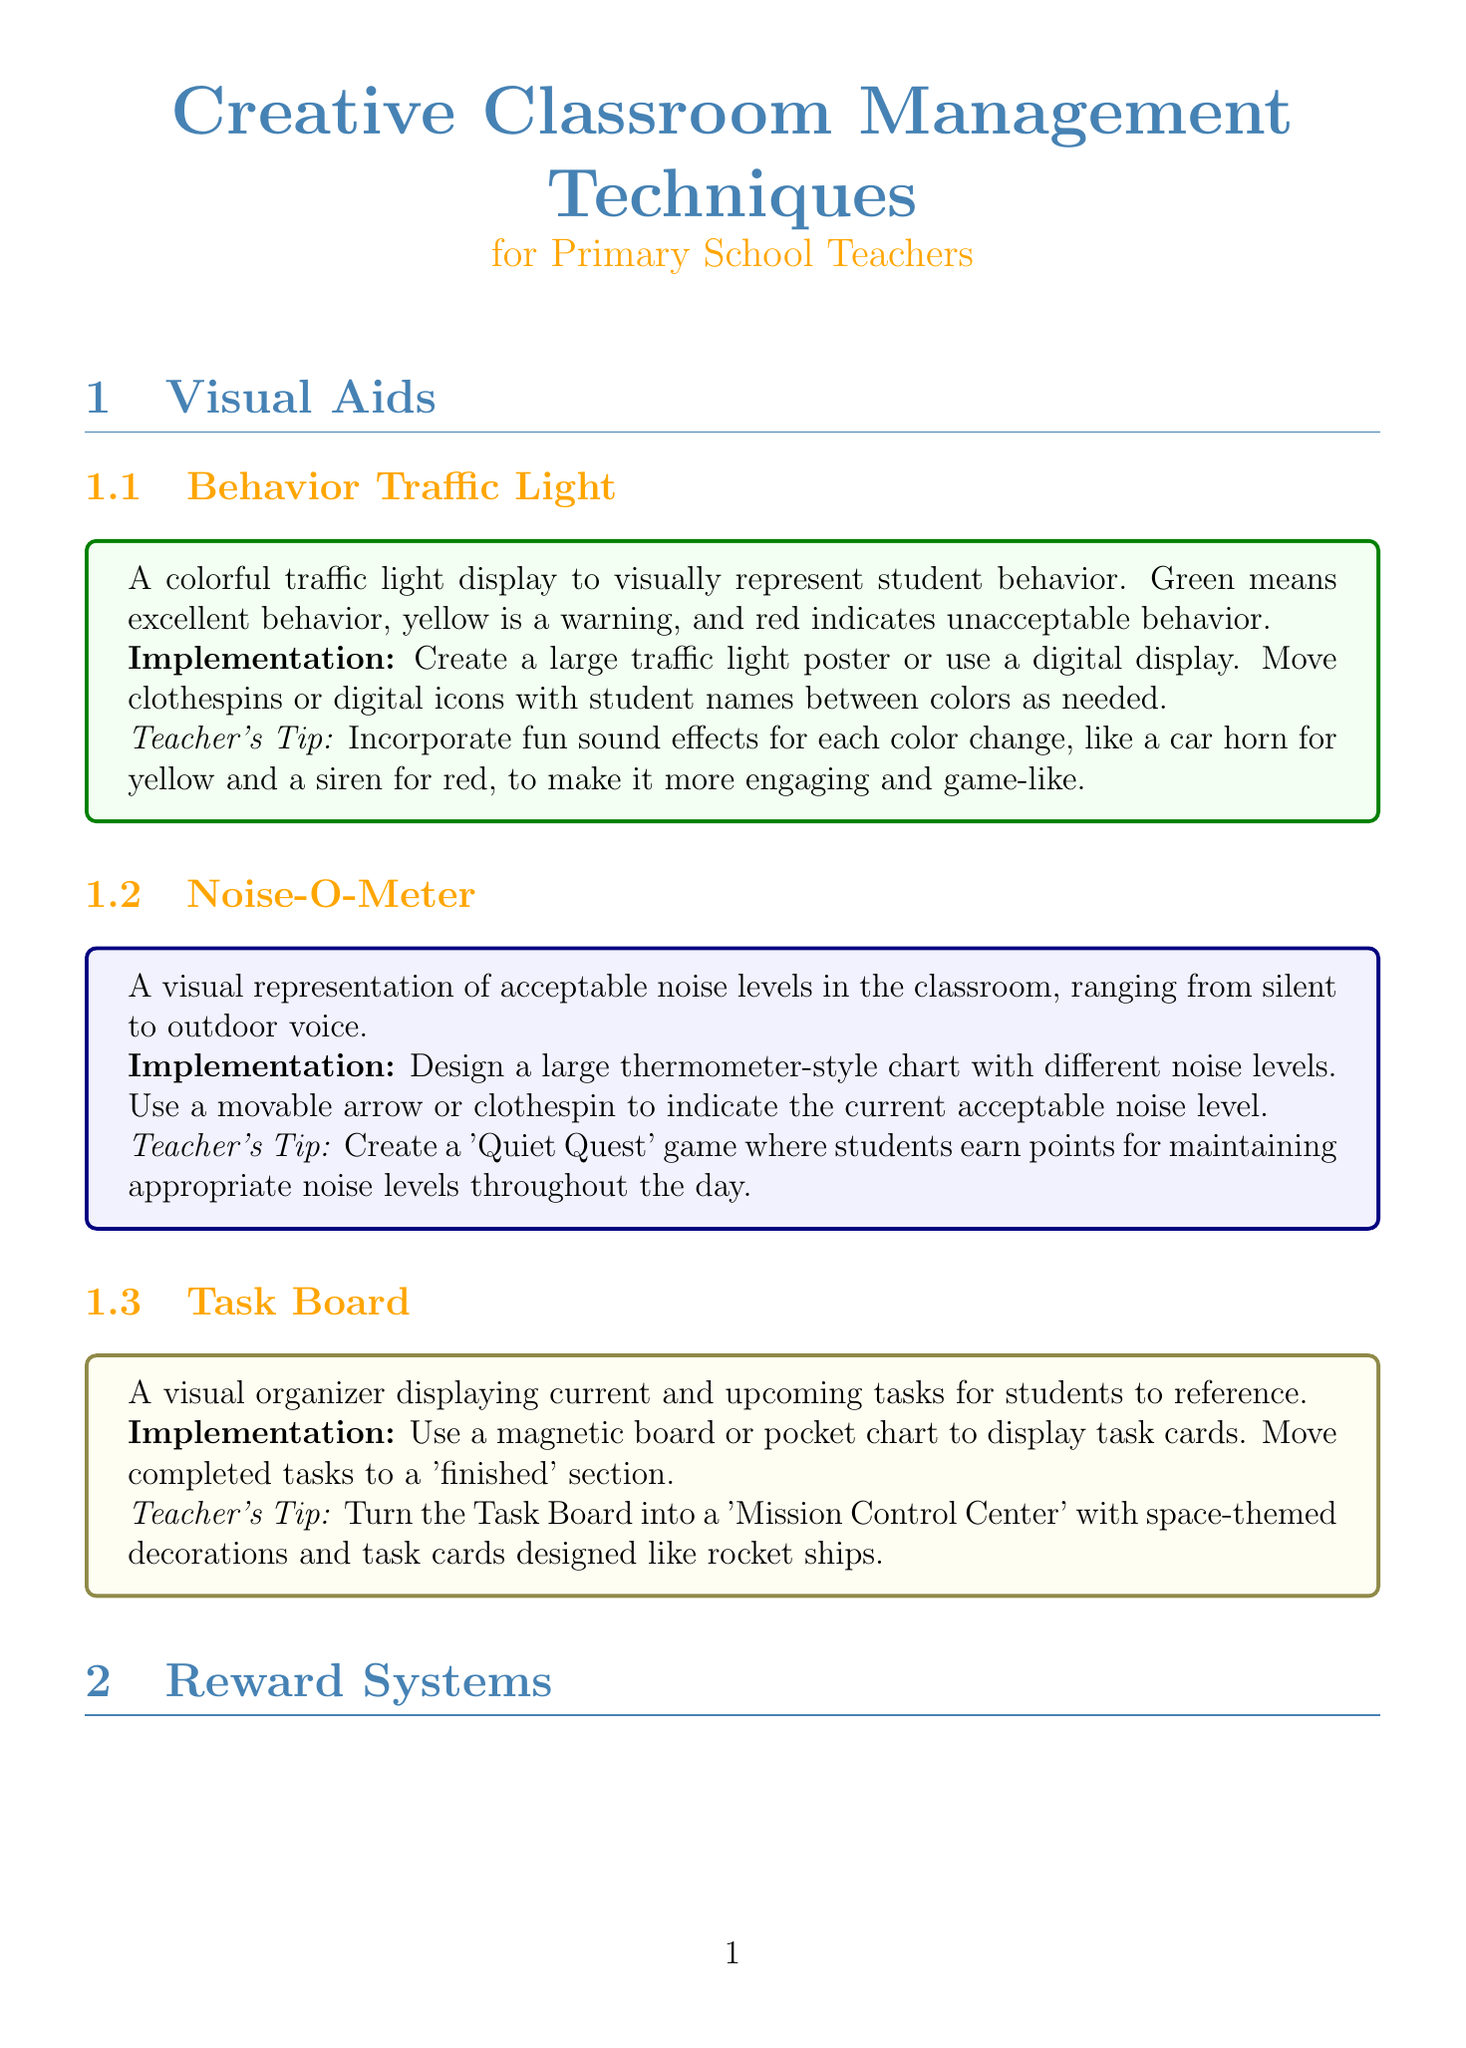What is the name of the first visual aid? The first visual aid is listed as "Behavior Traffic Light" in the document.
Answer: Behavior Traffic Light How many subsections are under Reward Systems? The document lists three subsections under Reward Systems: Class Dojo, Marble Jar, and Caught Being Good Cards.
Answer: 3 What implementation method is suggested for the Noise-O-Meter? The implementation method for the Noise-O-Meter is to design a large thermometer-style chart with different noise levels.
Answer: Large thermometer-style chart What is the full title of the manual? The full title is connected to the focus of the document, indicating it is for primary school teachers.
Answer: Creative Classroom Management Techniques for Primary School Teachers Which game is associated with the Marble Jar reward system? The Marble Jar system includes themed jars which can also be seen as a creative game-like structure for student engagement.
Answer: Themed marble jars How is the Task Board suggested to be turned into a fun theme? The document mentions that the Task Board can be turned into a “Mission Control Center” with space-themed decorations.
Answer: Mission Control Center What type of challenge is proposed for the Clean-Up Race? The Clean-Up Race is proposed as a timed challenge to encourage students to clean up quickly.
Answer: Timed challenge What teacher's tip is given for the Mystery Motivator? The tip includes using invisible ink and special glasses to reveal rewards, adding a fun element to the motivation.
Answer: Invisible ink and detective glasses 